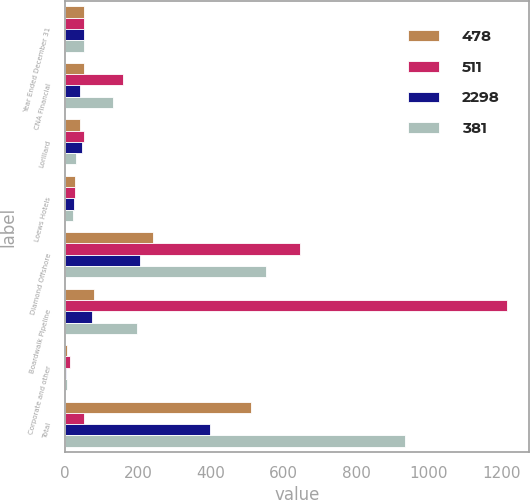Convert chart. <chart><loc_0><loc_0><loc_500><loc_500><stacked_bar_chart><ecel><fcel>Year Ended December 31<fcel>CNA Financial<fcel>Lorillard<fcel>Loews Hotels<fcel>Diamond Offshore<fcel>Boardwalk Pipeline<fcel>Corporate and other<fcel>Total<nl><fcel>478<fcel>53<fcel>53<fcel>40<fcel>26<fcel>241<fcel>80<fcel>4<fcel>511<nl><fcel>511<fcel>53<fcel>160<fcel>51<fcel>27<fcel>647<fcel>1214<fcel>14<fcel>53<nl><fcel>2298<fcel>53<fcel>42<fcel>47<fcel>25<fcel>207<fcel>75<fcel>3<fcel>399<nl><fcel>381<fcel>53<fcel>131<fcel>30<fcel>21<fcel>551<fcel>197<fcel>4<fcel>934<nl></chart> 